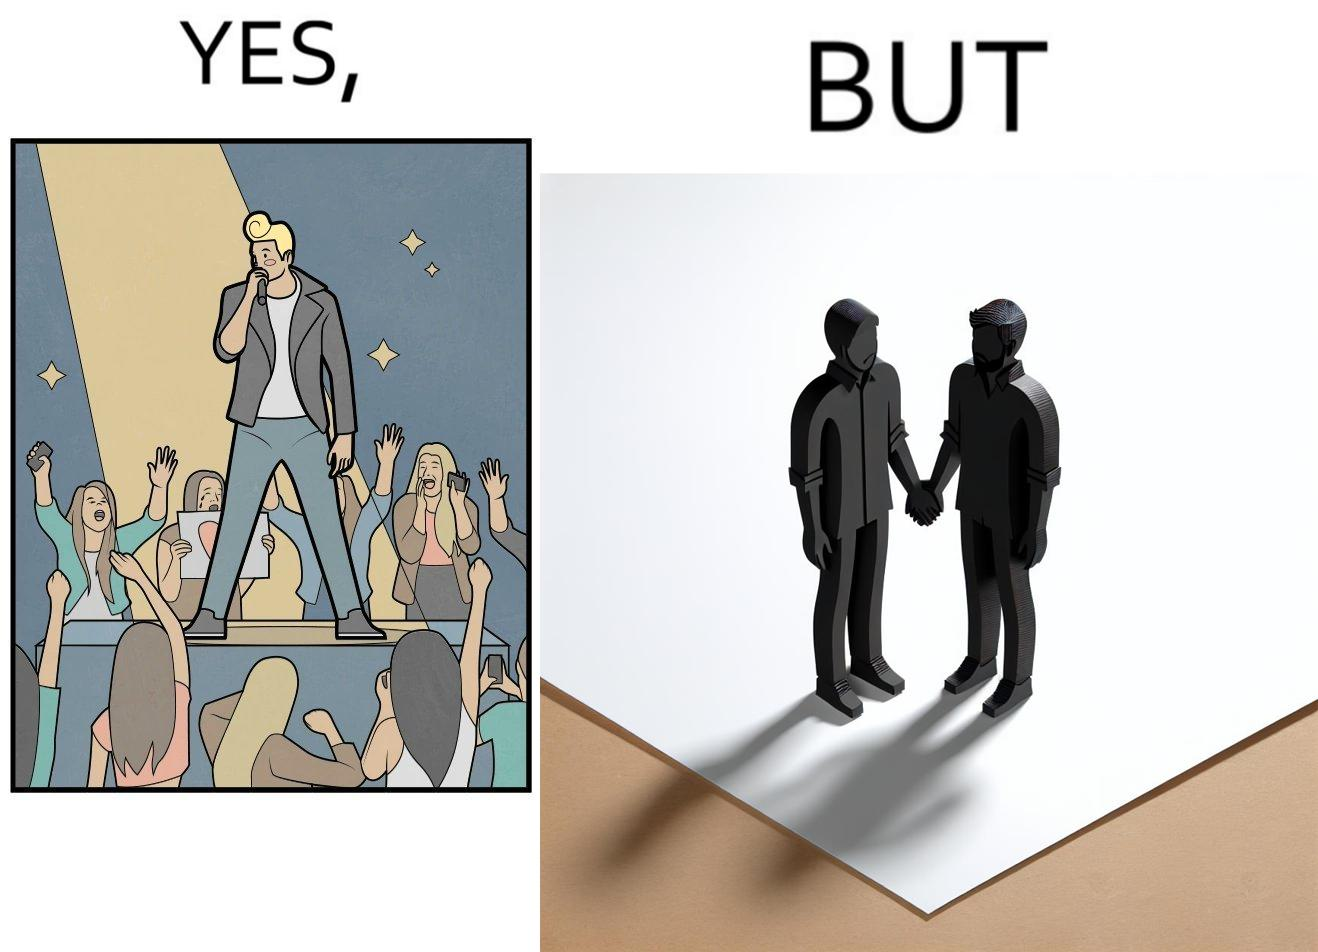Is this image satirical or non-satirical? Yes, this image is satirical. 